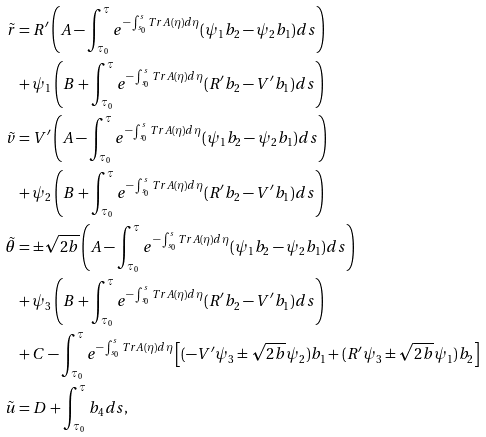<formula> <loc_0><loc_0><loc_500><loc_500>\tilde { r } & = R ^ { \prime } \left ( A - \int _ { \tau _ { 0 } } ^ { \tau } e ^ { - \int _ { s _ { 0 } } ^ { s } T r A ( \eta ) d \eta } ( \psi _ { 1 } b _ { 2 } - \psi _ { 2 } b _ { 1 } ) d s \right ) \\ & + \psi _ { 1 } \left ( B + \int _ { \tau _ { 0 } } ^ { \tau } e ^ { - \int _ { s _ { 0 } } ^ { s } T r A ( \eta ) d \eta } ( R ^ { \prime } b _ { 2 } - V ^ { \prime } b _ { 1 } ) d s \right ) \\ \tilde { v } & = V ^ { \prime } \left ( A - \int _ { \tau _ { 0 } } ^ { \tau } e ^ { - \int _ { s _ { 0 } } ^ { s } T r A ( \eta ) d \eta } ( \psi _ { 1 } b _ { 2 } - \psi _ { 2 } b _ { 1 } ) d s \right ) \\ & + \psi _ { 2 } \left ( B + \int _ { \tau _ { 0 } } ^ { \tau } e ^ { - \int _ { s _ { 0 } } ^ { s } T r A ( \eta ) d \eta } ( R ^ { \prime } b _ { 2 } - V ^ { \prime } b _ { 1 } ) d s \right ) \\ \tilde { \theta } & = \pm \sqrt { 2 b } \left ( A - \int _ { \tau _ { 0 } } ^ { \tau } e ^ { - \int _ { s _ { 0 } } ^ { s } T r A ( \eta ) d \eta } ( \psi _ { 1 } b _ { 2 } - \psi _ { 2 } b _ { 1 } ) d s \right ) \\ & + \psi _ { 3 } \left ( B + \int _ { \tau _ { 0 } } ^ { \tau } e ^ { - \int _ { s _ { 0 } } ^ { s } T r A ( \eta ) d \eta } ( R ^ { \prime } b _ { 2 } - V ^ { \prime } b _ { 1 } ) d s \right ) \\ & + C - \int _ { \tau _ { 0 } } ^ { \tau } e ^ { - \int _ { s _ { 0 } } ^ { s } T r A ( \eta ) d \eta } \left [ ( - V ^ { \prime } \psi _ { 3 } \pm \sqrt { 2 b } \psi _ { 2 } ) b _ { 1 } + ( R ^ { \prime } \psi _ { 3 } \pm \sqrt { 2 b } \psi _ { 1 } ) b _ { 2 } \right ] \\ \tilde { u } & = D + \int _ { \tau _ { 0 } } ^ { \tau } b _ { 4 } d s ,</formula> 